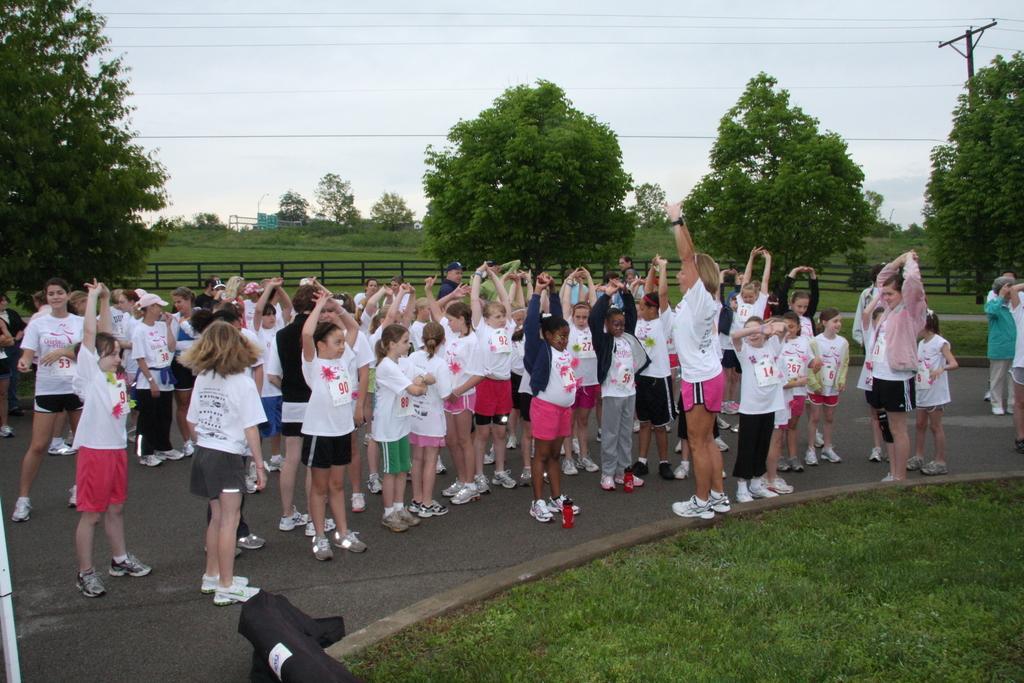Describe this image in one or two sentences. In this image there are few kids standing on the road. Right bottom there is grassland. Right side there are few persons standing on the road. Background there are few trees on the grassland having a fence. Right side there is a pole connected with wires. Top of the image there is sky. 